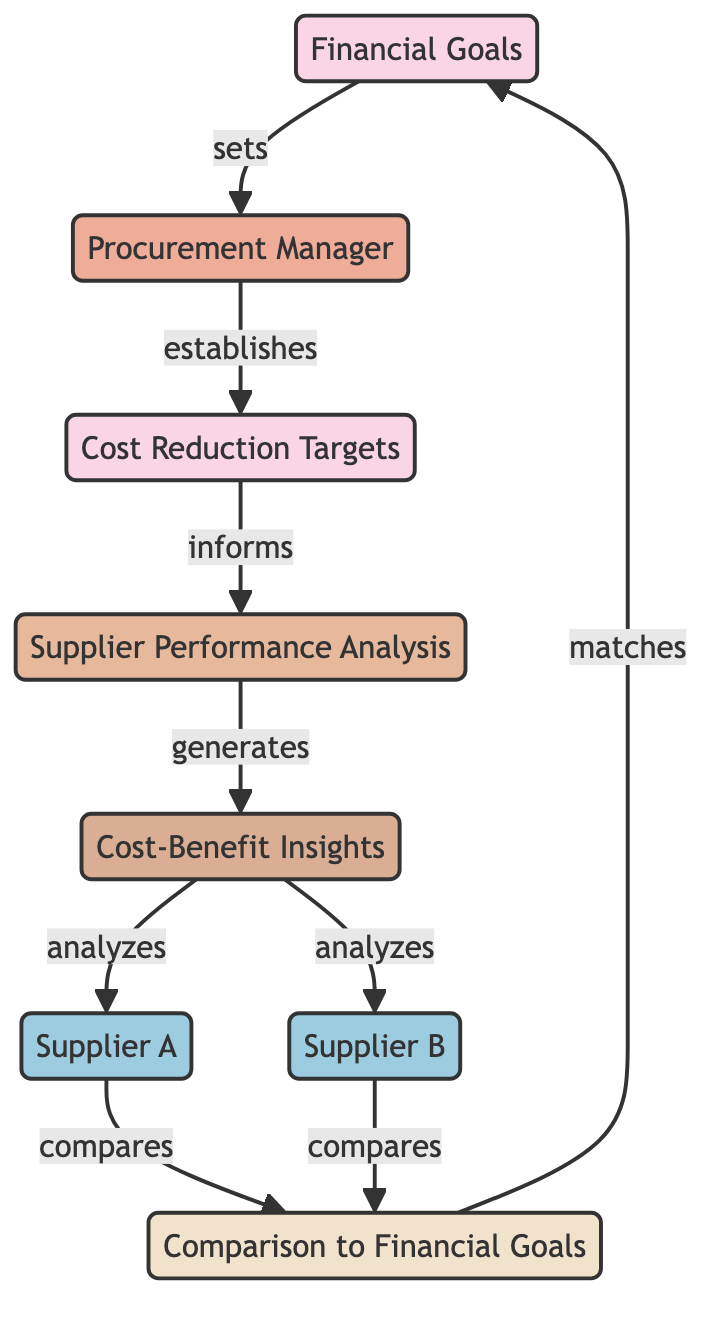What's the main responsibility of the procurement manager? The diagram shows that the procurement manager establishes cost reduction targets. This is indicated by the directional flow from the procurement manager to cost reduction targets in the diagram.
Answer: Establishes cost reduction targets How many suppliers are analyzed in the cost-benefit insights? The diagram specifies two suppliers, Supplier A and Supplier B, both of which are mentioned as being analyzed in the cost-benefit insights section.
Answer: Two What do cost reduction targets inform? According to the flow in the diagram, cost reduction targets inform the supplier performance analysis, as demonstrated by the arrow leading from cost reduction targets to supplier performance analysis.
Answer: Supplier performance analysis Which node receives insights from the supplier performance analysis? Cost-benefit insights receive analysis from supplier performance analysis, as indicated by the arrow flowing from supplier performance analysis to cost-benefit insights in the diagram.
Answer: Cost-benefit insights What is compared to financial goals? The comparison to financial goals involves supplier A and supplier B, as stated in the diagram where each supplier is connected to the comparison node, which then relates to financial goals.
Answer: Supplier A and Supplier B How does the procurement manager relate to financial goals? The procurement manager sets the financial goals, indicated by the direct linkage from the financial goals node to the procurement manager node in the diagram.
Answer: Sets What step follows the generation of cost-benefit insights? Following the generation of cost-benefit insights, supplier A and supplier B are analyzed, which is shown by the connections leading from cost-benefit insights to each supplier node.
Answer: Analysis of Supplier A and Supplier B How do supplier performances relate to financial goals? Supplier performances (Supplier A and Supplier B) are compared to financial goals, with the comparison financial goals node connected to each supplier, indicating that their performance is assessed against these goals.
Answer: Comparison to financial goals What does the arrow from cost-benefit insights to supplier A signify? This arrow signifies that cost-benefit insights analyze supplier A, showing the flow of information in the analysis process from insights to supplier performance.
Answer: Analyzes Supplier A 